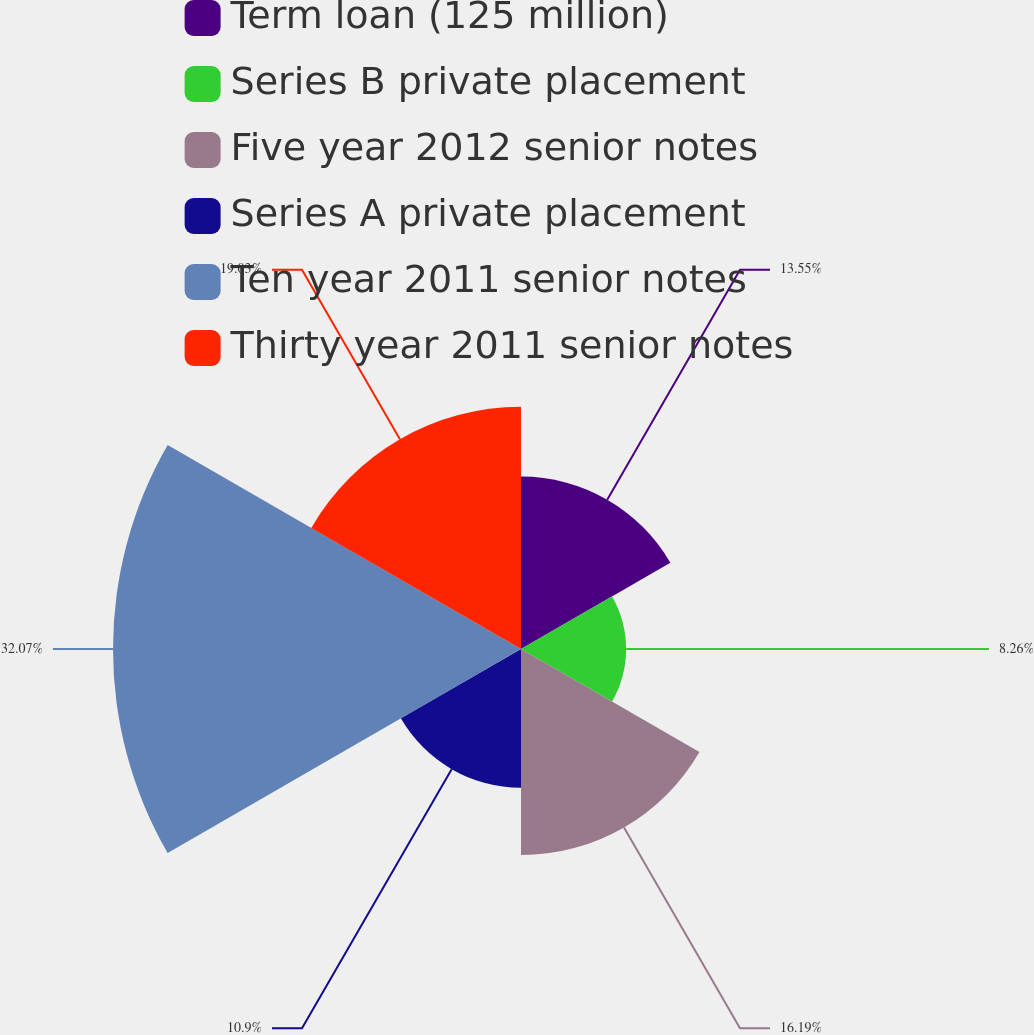Convert chart to OTSL. <chart><loc_0><loc_0><loc_500><loc_500><pie_chart><fcel>Term loan (125 million)<fcel>Series B private placement<fcel>Five year 2012 senior notes<fcel>Series A private placement<fcel>Ten year 2011 senior notes<fcel>Thirty year 2011 senior notes<nl><fcel>13.55%<fcel>8.26%<fcel>16.19%<fcel>10.9%<fcel>32.06%<fcel>19.03%<nl></chart> 